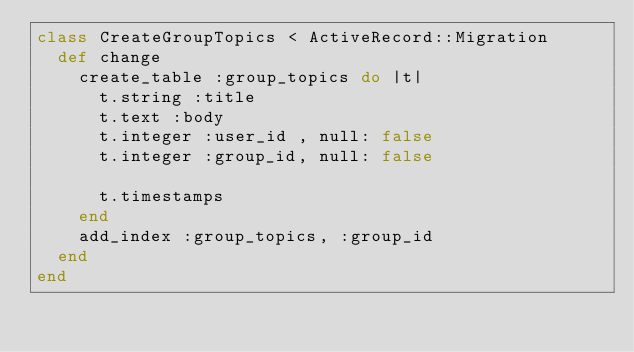Convert code to text. <code><loc_0><loc_0><loc_500><loc_500><_Ruby_>class CreateGroupTopics < ActiveRecord::Migration
  def change
    create_table :group_topics do |t|
      t.string :title
      t.text :body
      t.integer :user_id , null: false
      t.integer :group_id, null: false

      t.timestamps
    end
    add_index :group_topics, :group_id
  end
end
</code> 